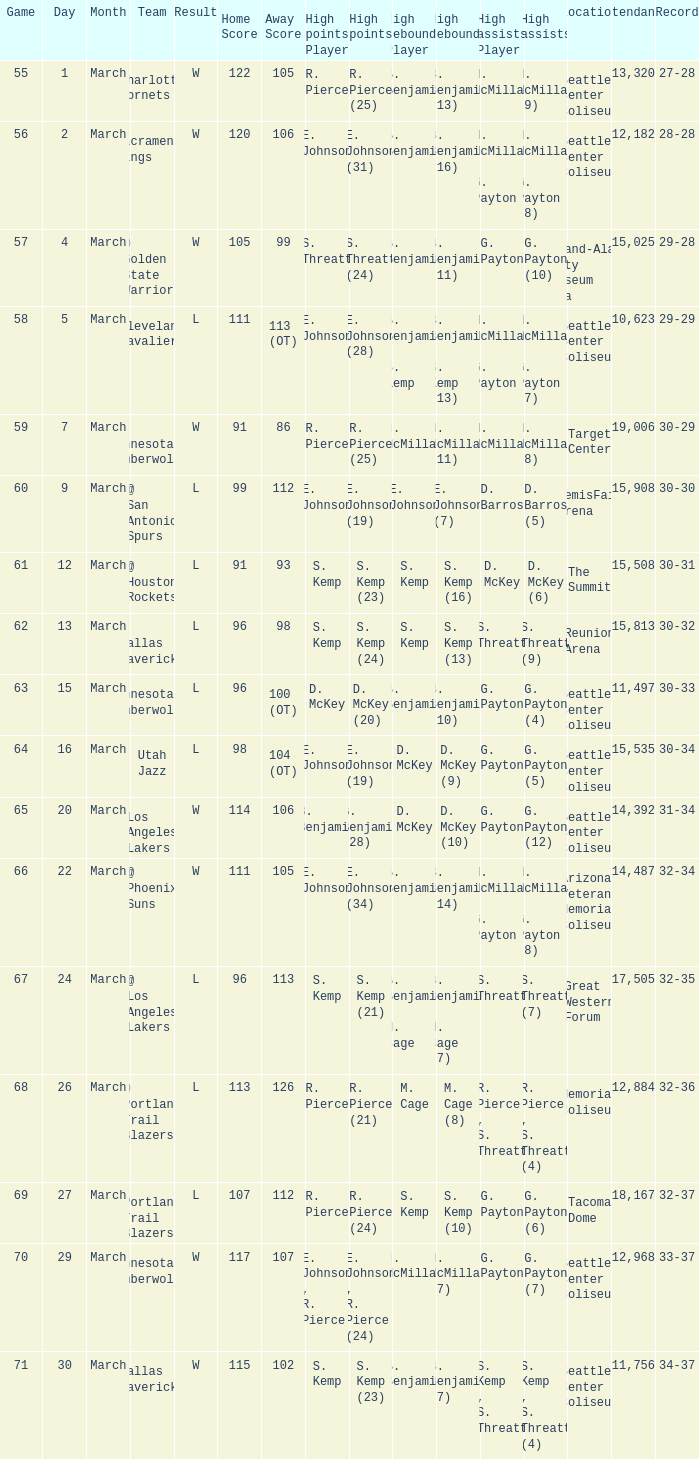Could you parse the entire table? {'header': ['Game', 'Day', 'Month', 'Team', 'Result', 'Home Score', 'Away Score', 'High points Player', 'High points', 'High rebounds Player', 'High rebounds', 'High assists Player', 'High assists', 'Location', 'Attendance', 'Record'], 'rows': [['55', '1', 'March', 'Charlotte Hornets', 'W', '122', '105', 'R. Pierce', 'R. Pierce (25)', 'B. Benjamin', 'B. Benjamin (13)', 'N. McMillan', 'N. McMillan (9)', 'Seattle Center Coliseum', '13,320', '27-28'], ['56', '2', 'March', 'Sacramento Kings', 'W', '120', '106', 'E. Johnson', 'E. Johnson (31)', 'B. Benjamin', 'B. Benjamin (16)', 'N. McMillan , G. Payton', 'N. McMillan , G. Payton (8)', 'Seattle Center Coliseum', '12,182', '28-28'], ['57', '4', 'March', '@ Golden State Warriors', 'W', '105', '99', 'S. Threatt', 'S. Threatt (24)', 'B. Benjamin', 'B. Benjamin (11)', 'G. Payton', 'G. Payton (10)', 'Oakland-Alameda County Coliseum Arena', '15,025', '29-28'], ['58', '5', 'March', 'Cleveland Cavaliers', 'L', '111', '113 (OT)', 'E. Johnson', 'E. Johnson (28)', 'B. Benjamin , S. Kemp', 'B. Benjamin , S. Kemp (13)', 'N. McMillan , G. Payton', 'N. McMillan , G. Payton (7)', 'Seattle Center Coliseum', '10,623', '29-29'], ['59', '7', 'March', '@ Minnesota Timberwolves', 'W', '91', '86', 'R. Pierce', 'R. Pierce (25)', 'N. McMillan', 'N. McMillan (11)', 'N. McMillan', 'N. McMillan (8)', 'Target Center', '19,006', '30-29'], ['60', '9', 'March', '@ San Antonio Spurs', 'L', '99', '112', 'E. Johnson', 'E. Johnson (19)', 'E. Johnson', 'E. Johnson (7)', 'D. Barros', 'D. Barros (5)', 'HemisFair Arena', '15,908', '30-30'], ['61', '12', 'March', '@ Houston Rockets', 'L', '91', '93', 'S. Kemp', 'S. Kemp (23)', 'S. Kemp', 'S. Kemp (16)', 'D. McKey', 'D. McKey (6)', 'The Summit', '15,508', '30-31'], ['62', '13', 'March', '@ Dallas Mavericks', 'L', '96', '98', 'S. Kemp', 'S. Kemp (24)', 'S. Kemp', 'S. Kemp (13)', 'S. Threatt', 'S. Threatt (9)', 'Reunion Arena', '15,813', '30-32'], ['63', '15', 'March', 'Minnesota Timberwolves', 'L', '96', '100 (OT)', 'D. McKey', 'D. McKey (20)', 'B. Benjamin', 'B. Benjamin (10)', 'G. Payton', 'G. Payton (4)', 'Seattle Center Coliseum', '11,497', '30-33'], ['64', '16', 'March', 'Utah Jazz', 'L', '98', '104 (OT)', 'E. Johnson', 'E. Johnson (19)', 'D. McKey', 'D. McKey (9)', 'G. Payton', 'G. Payton (5)', 'Seattle Center Coliseum', '15,535', '30-34'], ['65', '20', 'March', 'Los Angeles Lakers', 'W', '114', '106', 'B. Benjamin', 'B. Benjamin (28)', 'D. McKey', 'D. McKey (10)', 'G. Payton', 'G. Payton (12)', 'Seattle Center Coliseum', '14,392', '31-34'], ['66', '22', 'March', '@ Phoenix Suns', 'W', '111', '105', 'E. Johnson', 'E. Johnson (34)', 'B. Benjamin', 'B. Benjamin (14)', 'N. McMillan , G. Payton', 'N. McMillan , G. Payton (8)', 'Arizona Veterans Memorial Coliseum', '14,487', '32-34'], ['67', '24', 'March', '@ Los Angeles Lakers', 'L', '96', '113', 'S. Kemp', 'S. Kemp (21)', 'B. Benjamin , M. Cage', 'B. Benjamin , M. Cage (7)', 'S. Threatt', 'S. Threatt (7)', 'Great Western Forum', '17,505', '32-35'], ['68', '26', 'March', '@ Portland Trail Blazers', 'L', '113', '126', 'R. Pierce', 'R. Pierce (21)', 'M. Cage', 'M. Cage (8)', 'R. Pierce , S. Threatt', 'R. Pierce , S. Threatt (4)', 'Memorial Coliseum', '12,884', '32-36'], ['69', '27', 'March', 'Portland Trail Blazers', 'L', '107', '112', 'R. Pierce', 'R. Pierce (24)', 'S. Kemp', 'S. Kemp (10)', 'G. Payton', 'G. Payton (6)', 'Tacoma Dome', '18,167', '32-37'], ['70', '29', 'March', 'Minnesota Timberwolves', 'W', '117', '107', 'E. Johnson , R. Pierce', 'E. Johnson , R. Pierce (24)', 'N. McMillan', 'N. McMillan (7)', 'G. Payton', 'G. Payton (7)', 'Seattle Center Coliseum', '12,968', '33-37'], ['71', '30', 'March', 'Dallas Mavericks', 'W', '115', '102', 'S. Kemp', 'S. Kemp (23)', 'B. Benjamin', 'B. Benjamin (7)', 'S. Kemp , S. Threatt', 'S. Kemp , S. Threatt (4)', 'Seattle Center Coliseum', '11,756', '34-37']]} WhichScore has a Location Attendance of seattle center coliseum 11,497? L 96-100 (OT). 